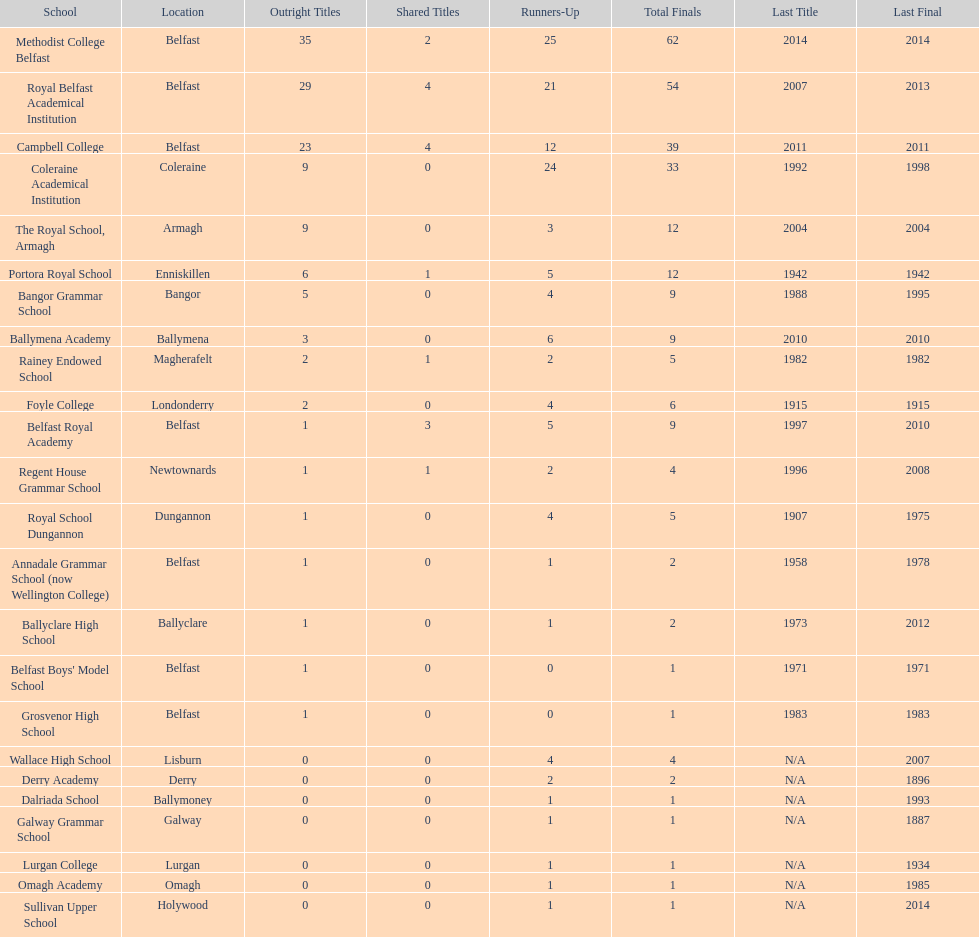Did belfast royal academy participate in a greater or lesser number of total finals compared to ballyclare high school? More. 